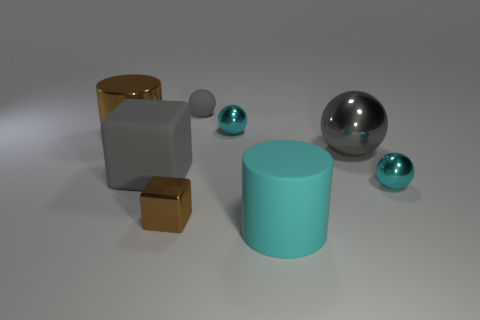Subtract all brown spheres. Subtract all brown cylinders. How many spheres are left? 4 Add 2 tiny gray spheres. How many objects exist? 10 Subtract all cubes. How many objects are left? 6 Add 4 gray rubber things. How many gray rubber things are left? 6 Add 6 cyan metal objects. How many cyan metal objects exist? 8 Subtract 0 blue cylinders. How many objects are left? 8 Subtract all gray metallic objects. Subtract all tiny gray things. How many objects are left? 6 